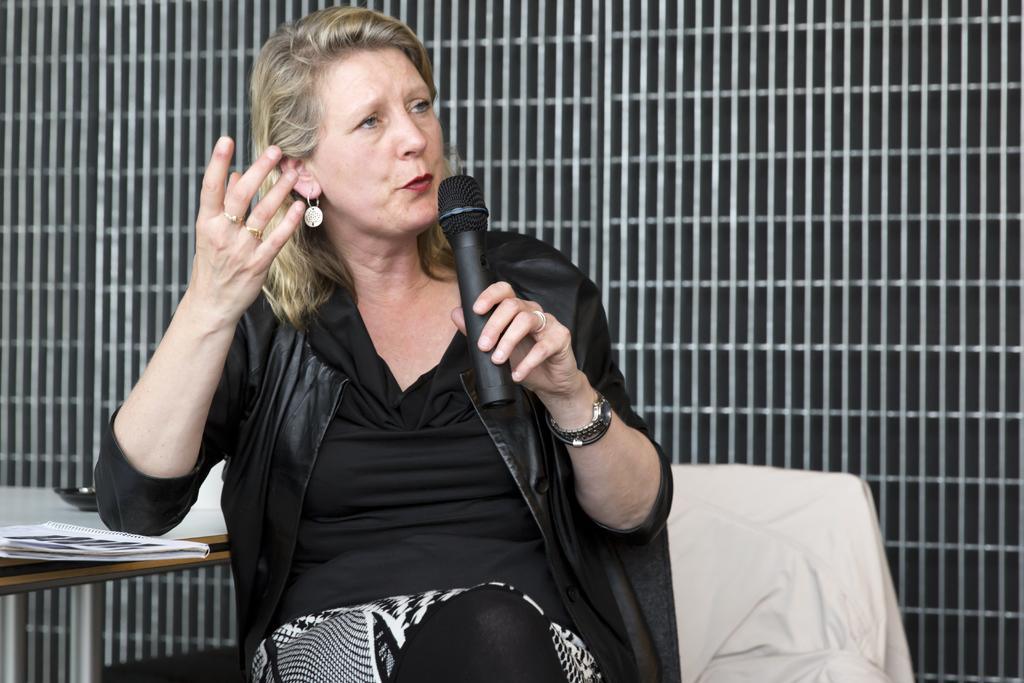Can you describe this image briefly? In this picture we can see woman sitting on chair holding mic in her hand and talking on it and the background we can see wall with rods, papers. 